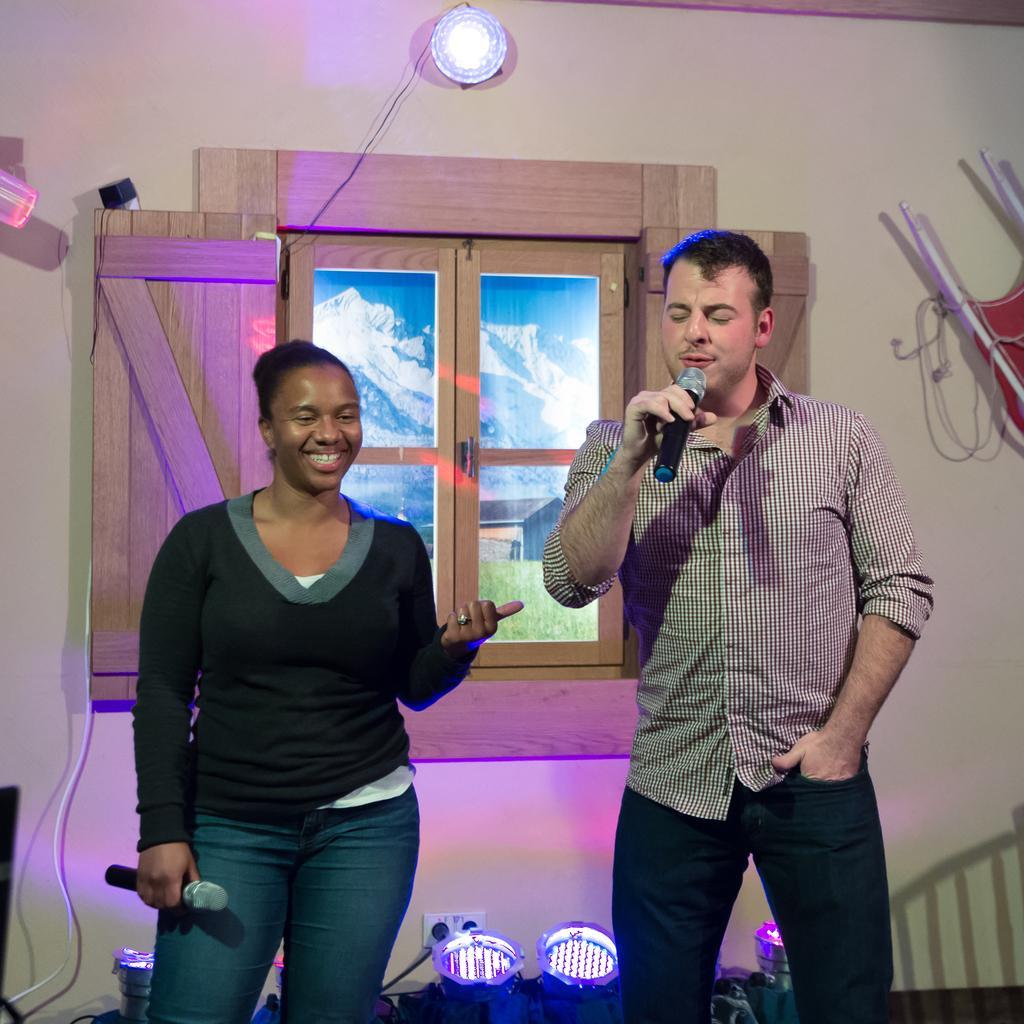How would you summarize this image in a sentence or two? The image is inside the room. In the image there are two people man and woman. Man and woman are holding a microphone on their hands and background there is a window which is closed mountains,houses,clock and a wall at bottom there are few lights. 